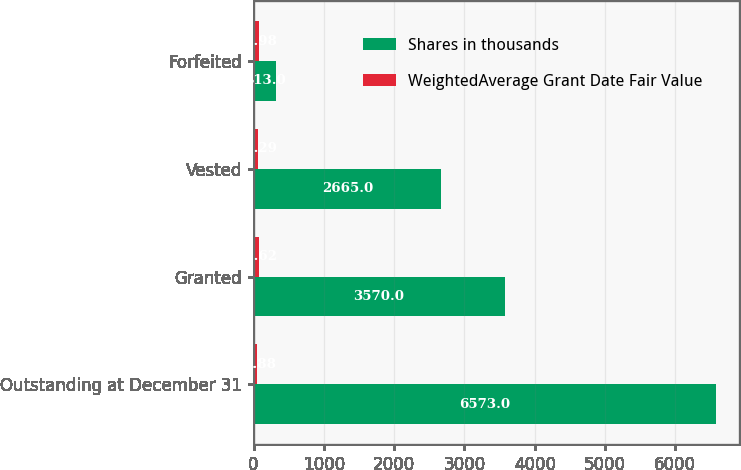<chart> <loc_0><loc_0><loc_500><loc_500><stacked_bar_chart><ecel><fcel>Outstanding at December 31<fcel>Granted<fcel>Vested<fcel>Forfeited<nl><fcel>Shares in thousands<fcel>6573<fcel>3570<fcel>2665<fcel>313<nl><fcel>WeightedAverage Grant Date Fair Value<fcel>51.88<fcel>78.62<fcel>62.29<fcel>72.98<nl></chart> 